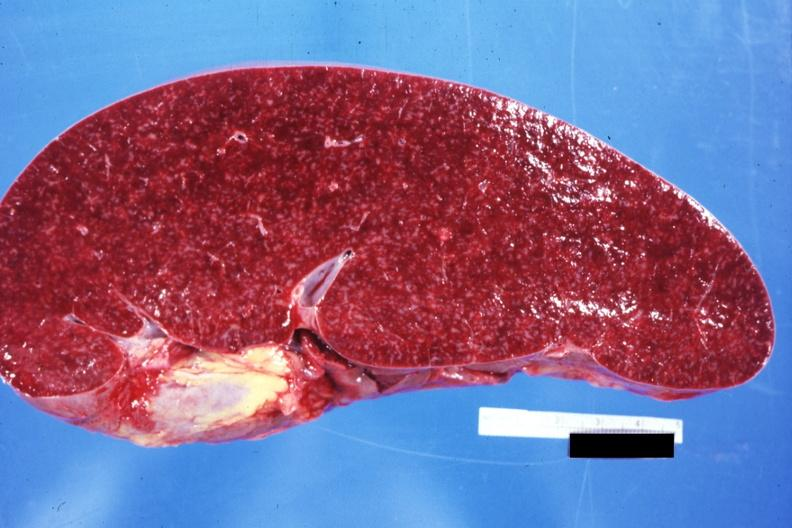what appears normal see other sides this case?
Answer the question using a single word or phrase. Cut surface prominent lymph follicles size 